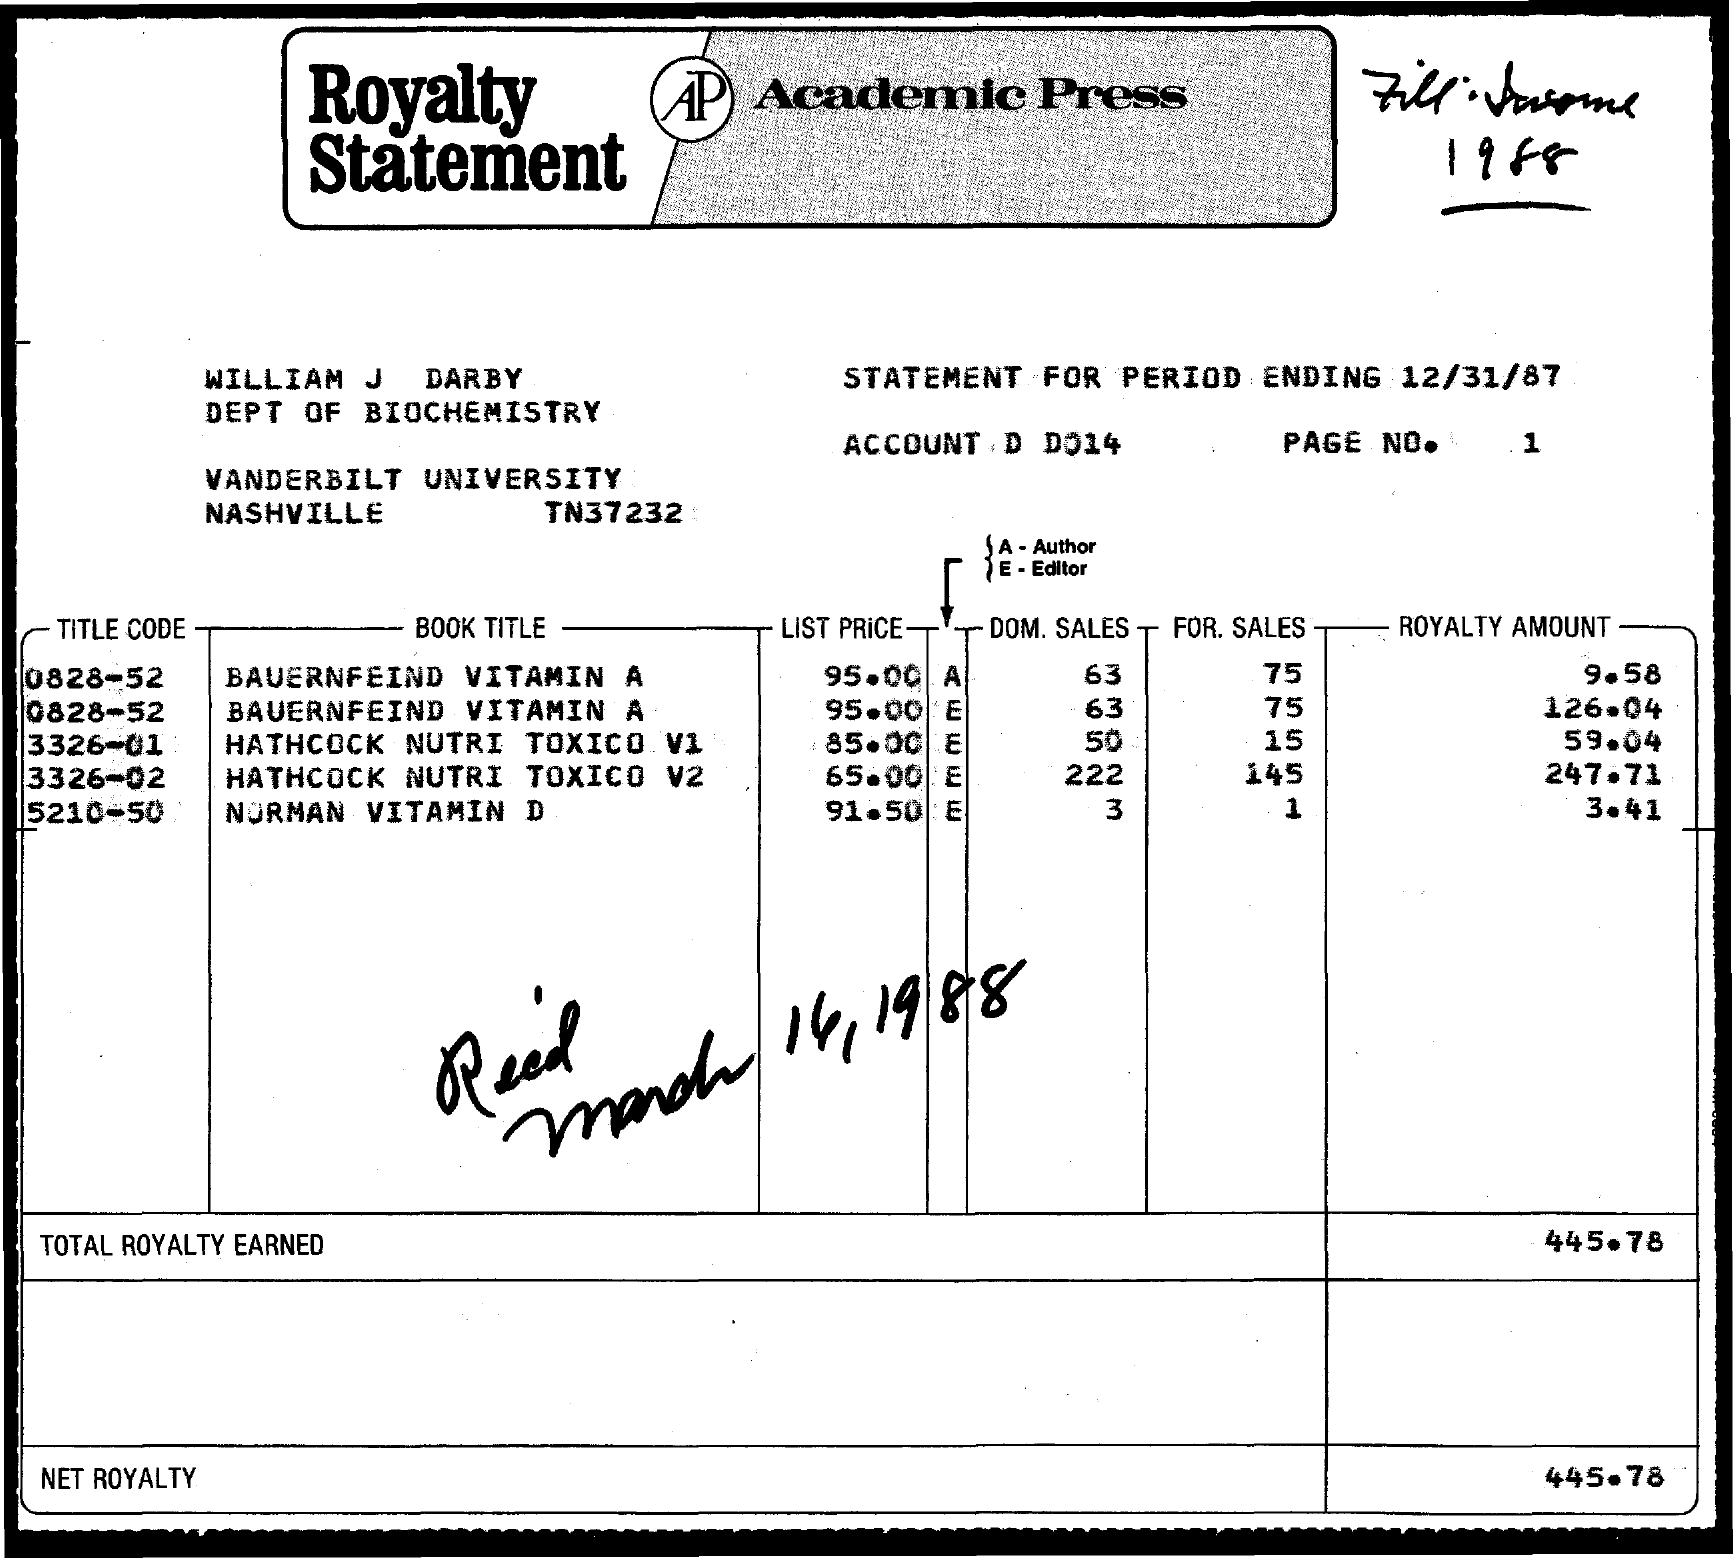Give some essential details in this illustration. The book title for the title code 0828-52 is "Vitamin A: The Bauernfeind Way. What is the domestic sales for the title code 5210-50? The current figure is 3. The list price for title code 5210-50 is 91.50. The book title for title code 5210-50 is "What is the Book Title for title code 5210-50? Norman Vitamin D..". I would like to request information regarding the For Sales title code 0828-52. Specifically, I am inquiring about the Sales for this particular code. The number I am requesting is 75... 